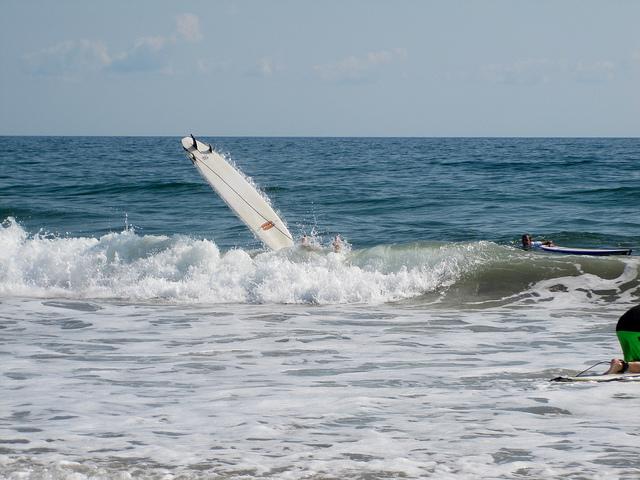Does the water look green?
Answer briefly. No. Is the surfboard going-over the wave or through it?
Keep it brief. Over. Where is the surfer?
Give a very brief answer. Water. Is there more than one person in this picture who is surfing?
Keep it brief. Yes. Could this surfer clear the crest of the wave?
Answer briefly. No. 